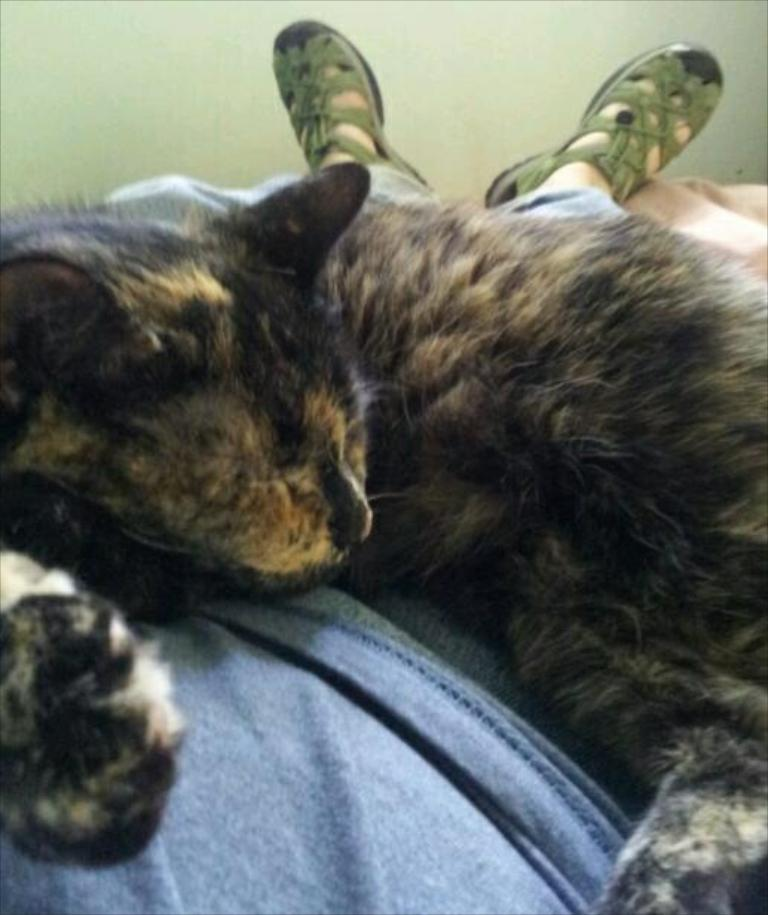What type of animal is in the image? There is a cat in the image. What is the cat doing in the image? The cat is sleeping. Where is the cat located in the image? The cat is on a man. What is the man doing in the image? The man is lying on a bed. What can be seen in the background of the image? There is a wall in the background of the image. What type of discovery was made in the jar in the image? There is no jar present in the image, so no discovery can be made from it. 